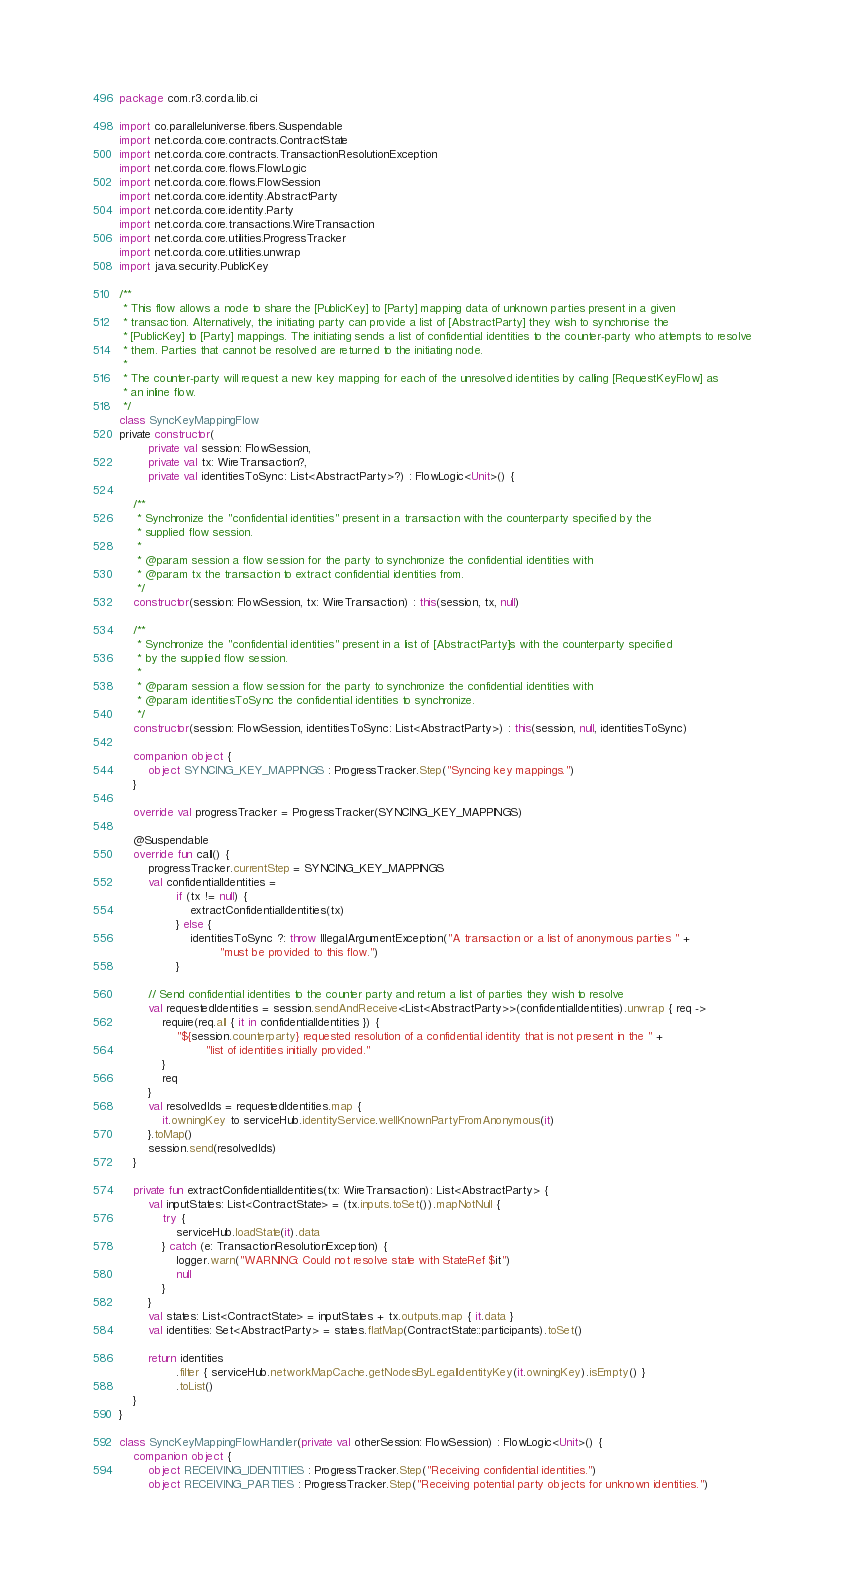Convert code to text. <code><loc_0><loc_0><loc_500><loc_500><_Kotlin_>package com.r3.corda.lib.ci

import co.paralleluniverse.fibers.Suspendable
import net.corda.core.contracts.ContractState
import net.corda.core.contracts.TransactionResolutionException
import net.corda.core.flows.FlowLogic
import net.corda.core.flows.FlowSession
import net.corda.core.identity.AbstractParty
import net.corda.core.identity.Party
import net.corda.core.transactions.WireTransaction
import net.corda.core.utilities.ProgressTracker
import net.corda.core.utilities.unwrap
import java.security.PublicKey

/**
 * This flow allows a node to share the [PublicKey] to [Party] mapping data of unknown parties present in a given
 * transaction. Alternatively, the initiating party can provide a list of [AbstractParty] they wish to synchronise the
 * [PublicKey] to [Party] mappings. The initiating sends a list of confidential identities to the counter-party who attempts to resolve
 * them. Parties that cannot be resolved are returned to the initiating node.
 *
 * The counter-party will request a new key mapping for each of the unresolved identities by calling [RequestKeyFlow] as
 * an inline flow.
 */
class SyncKeyMappingFlow
private constructor(
        private val session: FlowSession,
        private val tx: WireTransaction?,
        private val identitiesToSync: List<AbstractParty>?) : FlowLogic<Unit>() {

    /**
     * Synchronize the "confidential identities" present in a transaction with the counterparty specified by the
     * supplied flow session.
     *
     * @param session a flow session for the party to synchronize the confidential identities with
     * @param tx the transaction to extract confidential identities from.
     */
    constructor(session: FlowSession, tx: WireTransaction) : this(session, tx, null)

    /**
     * Synchronize the "confidential identities" present in a list of [AbstractParty]s with the counterparty specified
     * by the supplied flow session.
     *
     * @param session a flow session for the party to synchronize the confidential identities with
     * @param identitiesToSync the confidential identities to synchronize.
     */
    constructor(session: FlowSession, identitiesToSync: List<AbstractParty>) : this(session, null, identitiesToSync)

    companion object {
        object SYNCING_KEY_MAPPINGS : ProgressTracker.Step("Syncing key mappings.")
    }

    override val progressTracker = ProgressTracker(SYNCING_KEY_MAPPINGS)

    @Suspendable
    override fun call() {
        progressTracker.currentStep = SYNCING_KEY_MAPPINGS
        val confidentialIdentities =
                if (tx != null) {
                    extractConfidentialIdentities(tx)
                } else {
                    identitiesToSync ?: throw IllegalArgumentException("A transaction or a list of anonymous parties " +
                            "must be provided to this flow.")
                }

        // Send confidential identities to the counter party and return a list of parties they wish to resolve
        val requestedIdentities = session.sendAndReceive<List<AbstractParty>>(confidentialIdentities).unwrap { req ->
            require(req.all { it in confidentialIdentities }) {
                "${session.counterparty} requested resolution of a confidential identity that is not present in the " +
                        "list of identities initially provided."
            }
            req
        }
        val resolvedIds = requestedIdentities.map {
            it.owningKey to serviceHub.identityService.wellKnownPartyFromAnonymous(it)
        }.toMap()
        session.send(resolvedIds)
    }

    private fun extractConfidentialIdentities(tx: WireTransaction): List<AbstractParty> {
        val inputStates: List<ContractState> = (tx.inputs.toSet()).mapNotNull {
            try {
                serviceHub.loadState(it).data
            } catch (e: TransactionResolutionException) {
                logger.warn("WARNING: Could not resolve state with StateRef $it")
                null
            }
        }
        val states: List<ContractState> = inputStates + tx.outputs.map { it.data }
        val identities: Set<AbstractParty> = states.flatMap(ContractState::participants).toSet()

        return identities
                .filter { serviceHub.networkMapCache.getNodesByLegalIdentityKey(it.owningKey).isEmpty() }
                .toList()
    }
}

class SyncKeyMappingFlowHandler(private val otherSession: FlowSession) : FlowLogic<Unit>() {
    companion object {
        object RECEIVING_IDENTITIES : ProgressTracker.Step("Receiving confidential identities.")
        object RECEIVING_PARTIES : ProgressTracker.Step("Receiving potential party objects for unknown identities.")</code> 